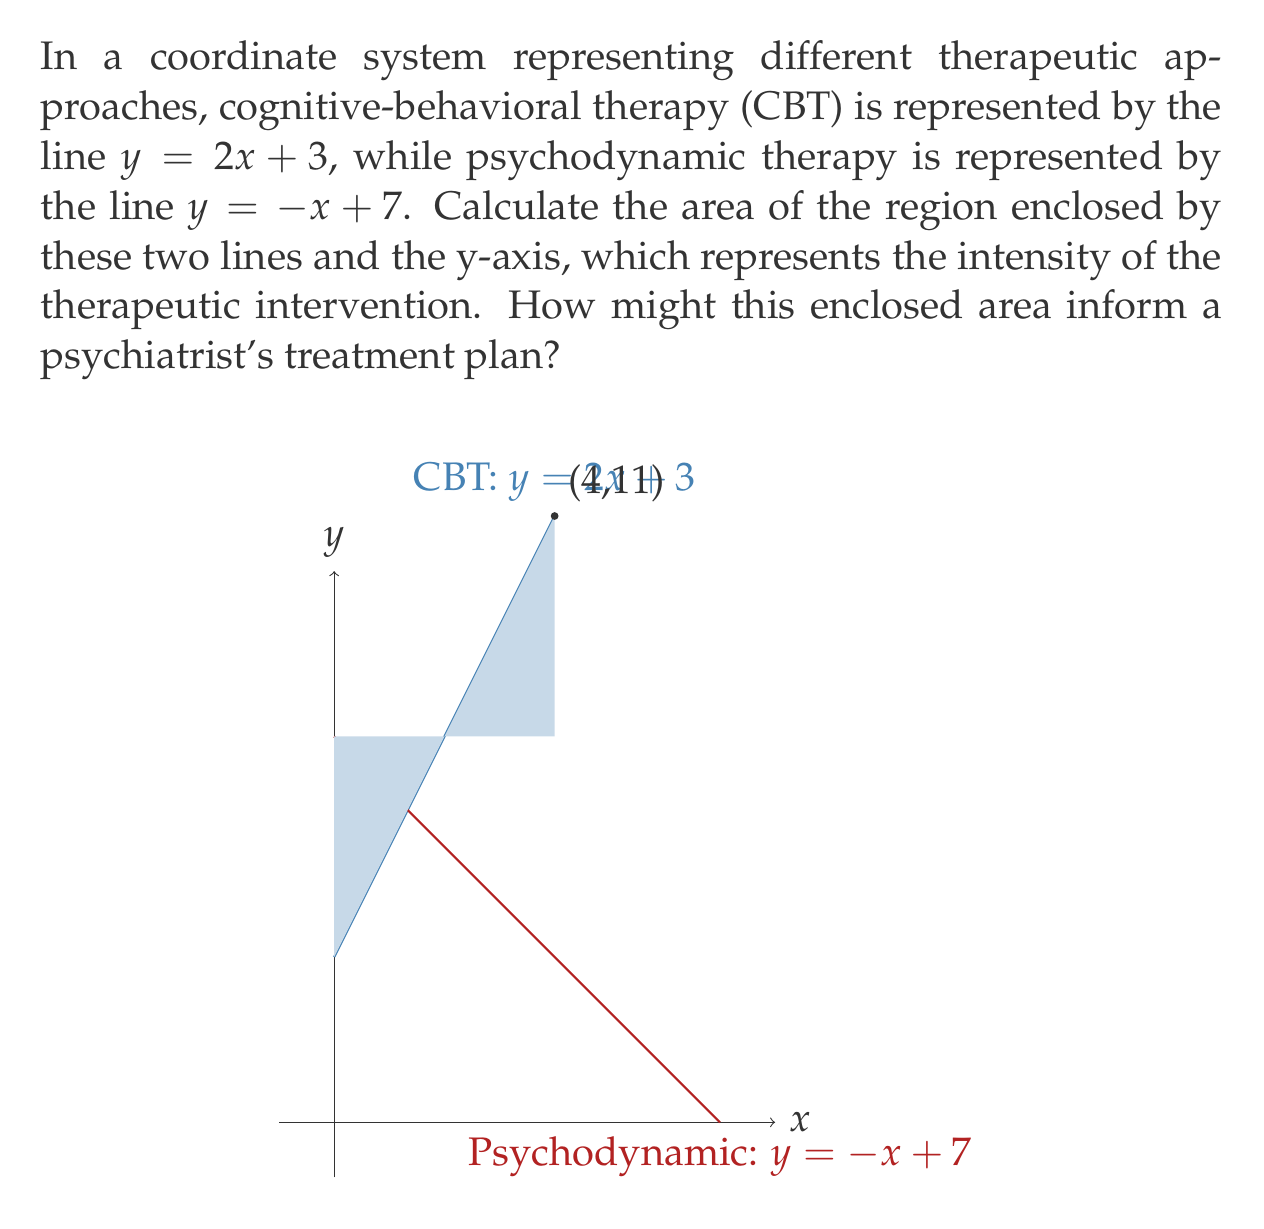Can you solve this math problem? To solve this problem, we'll follow these steps:

1) Find the point of intersection of the two lines.
2) Calculate the x-coordinate where the psychodynamic therapy line intersects the x-axis.
3) Use the formula for the area of a triangle to calculate the enclosed area.

Step 1: Find the point of intersection
Let's set the equations equal to each other:
$$2x + 3 = -x + 7$$
$$3x = 4$$
$$x = \frac{4}{3}$$

Substituting this x-value into either equation gives us the y-coordinate:
$$y = 2(\frac{4}{3}) + 3 = \frac{8}{3} + 3 = \frac{17}{3}$$

So the point of intersection is $(\frac{4}{3}, \frac{17}{3})$.

Step 2: Find where psychodynamic therapy line intersects x-axis
Set y = 0 in the equation $y = -x + 7$:
$$0 = -x + 7$$
$$x = 7$$

Step 3: Calculate the area
The enclosed region forms a triangle. We can calculate its area using the formula:
$$Area = \frac{1}{2} * base * height$$

The base is the x-coordinate where the psychodynamic line intersects the x-axis: 7.
The height is the y-coordinate of the intersection point: $\frac{17}{3}$.

Therefore, the area is:
$$Area = \frac{1}{2} * 7 * \frac{17}{3} = \frac{119}{6} \approx 19.83$$

This area represents the intensity and range of therapeutic interventions between CBT and psychodynamic approaches. A larger area might suggest a more comprehensive treatment plan incorporating elements from both approaches, while a smaller area might indicate a more focused approach. The psychiatrist could use this information to tailor the treatment plan to the patient's needs, potentially emphasizing one approach over the other or integrating both based on the calculated area.
Answer: The area enclosed by the two lines and the y-axis is $\frac{119}{6}$ square units or approximately 19.83 square units. 